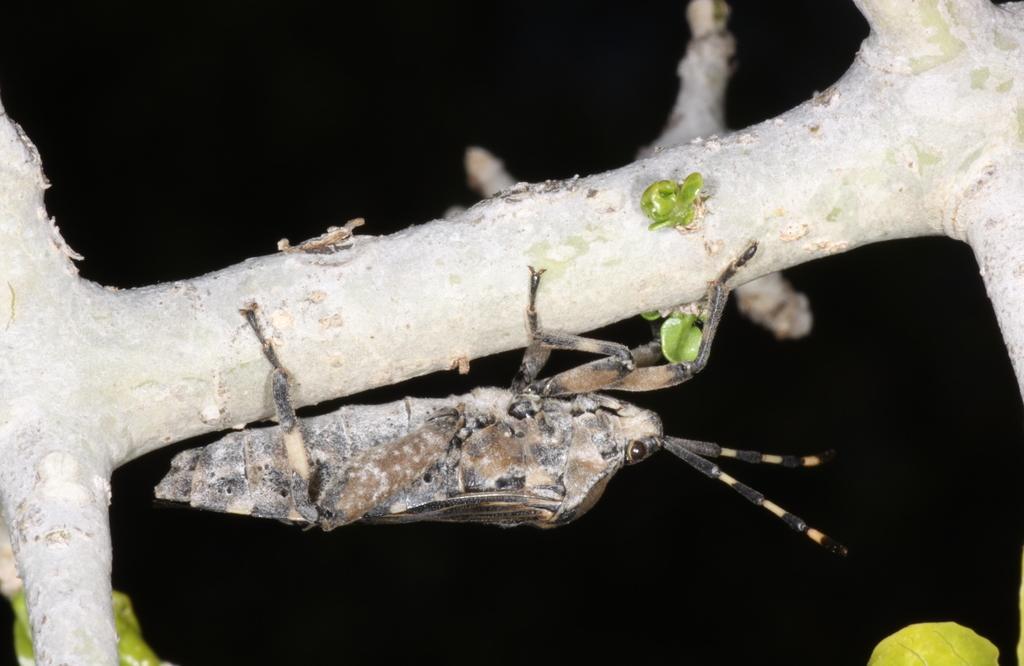In one or two sentences, can you explain what this image depicts? In the center of this picture we can see an insect and we can see the wooden object and the green leaves. The background of the image is very dark. 